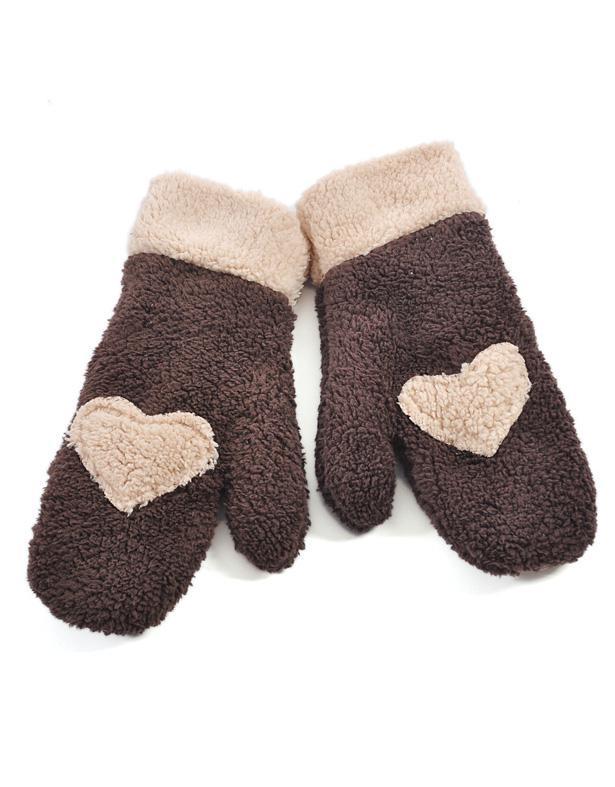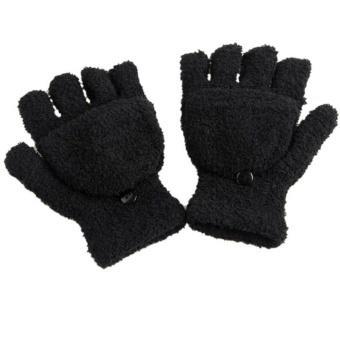The first image is the image on the left, the second image is the image on the right. Evaluate the accuracy of this statement regarding the images: "The left image contains one pair of mittens displayed with the cuff end up, and the right image features a pair of half-finger gloves with a mitten flap.". Is it true? Answer yes or no. Yes. The first image is the image on the left, the second image is the image on the right. Examine the images to the left and right. Is the description "The right image contains two finger less gloves." accurate? Answer yes or no. Yes. 